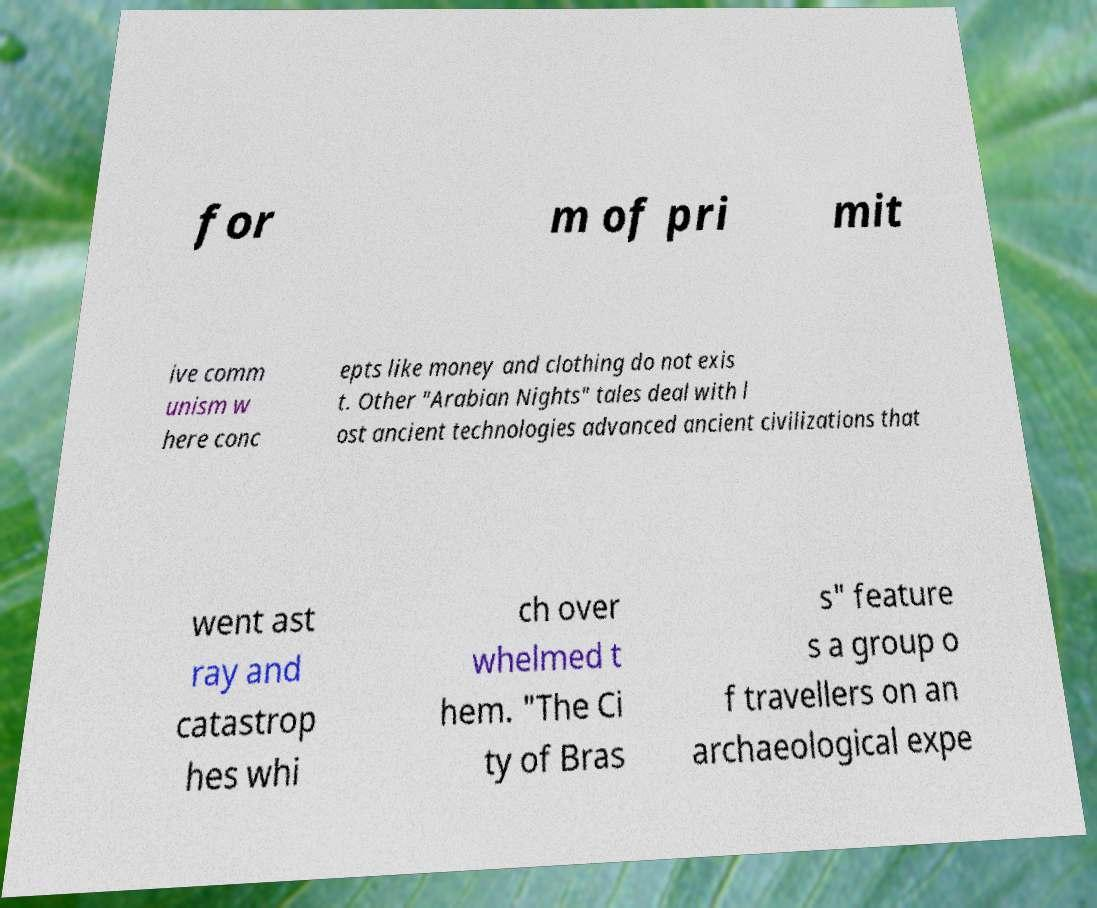What messages or text are displayed in this image? I need them in a readable, typed format. for m of pri mit ive comm unism w here conc epts like money and clothing do not exis t. Other "Arabian Nights" tales deal with l ost ancient technologies advanced ancient civilizations that went ast ray and catastrop hes whi ch over whelmed t hem. "The Ci ty of Bras s" feature s a group o f travellers on an archaeological expe 